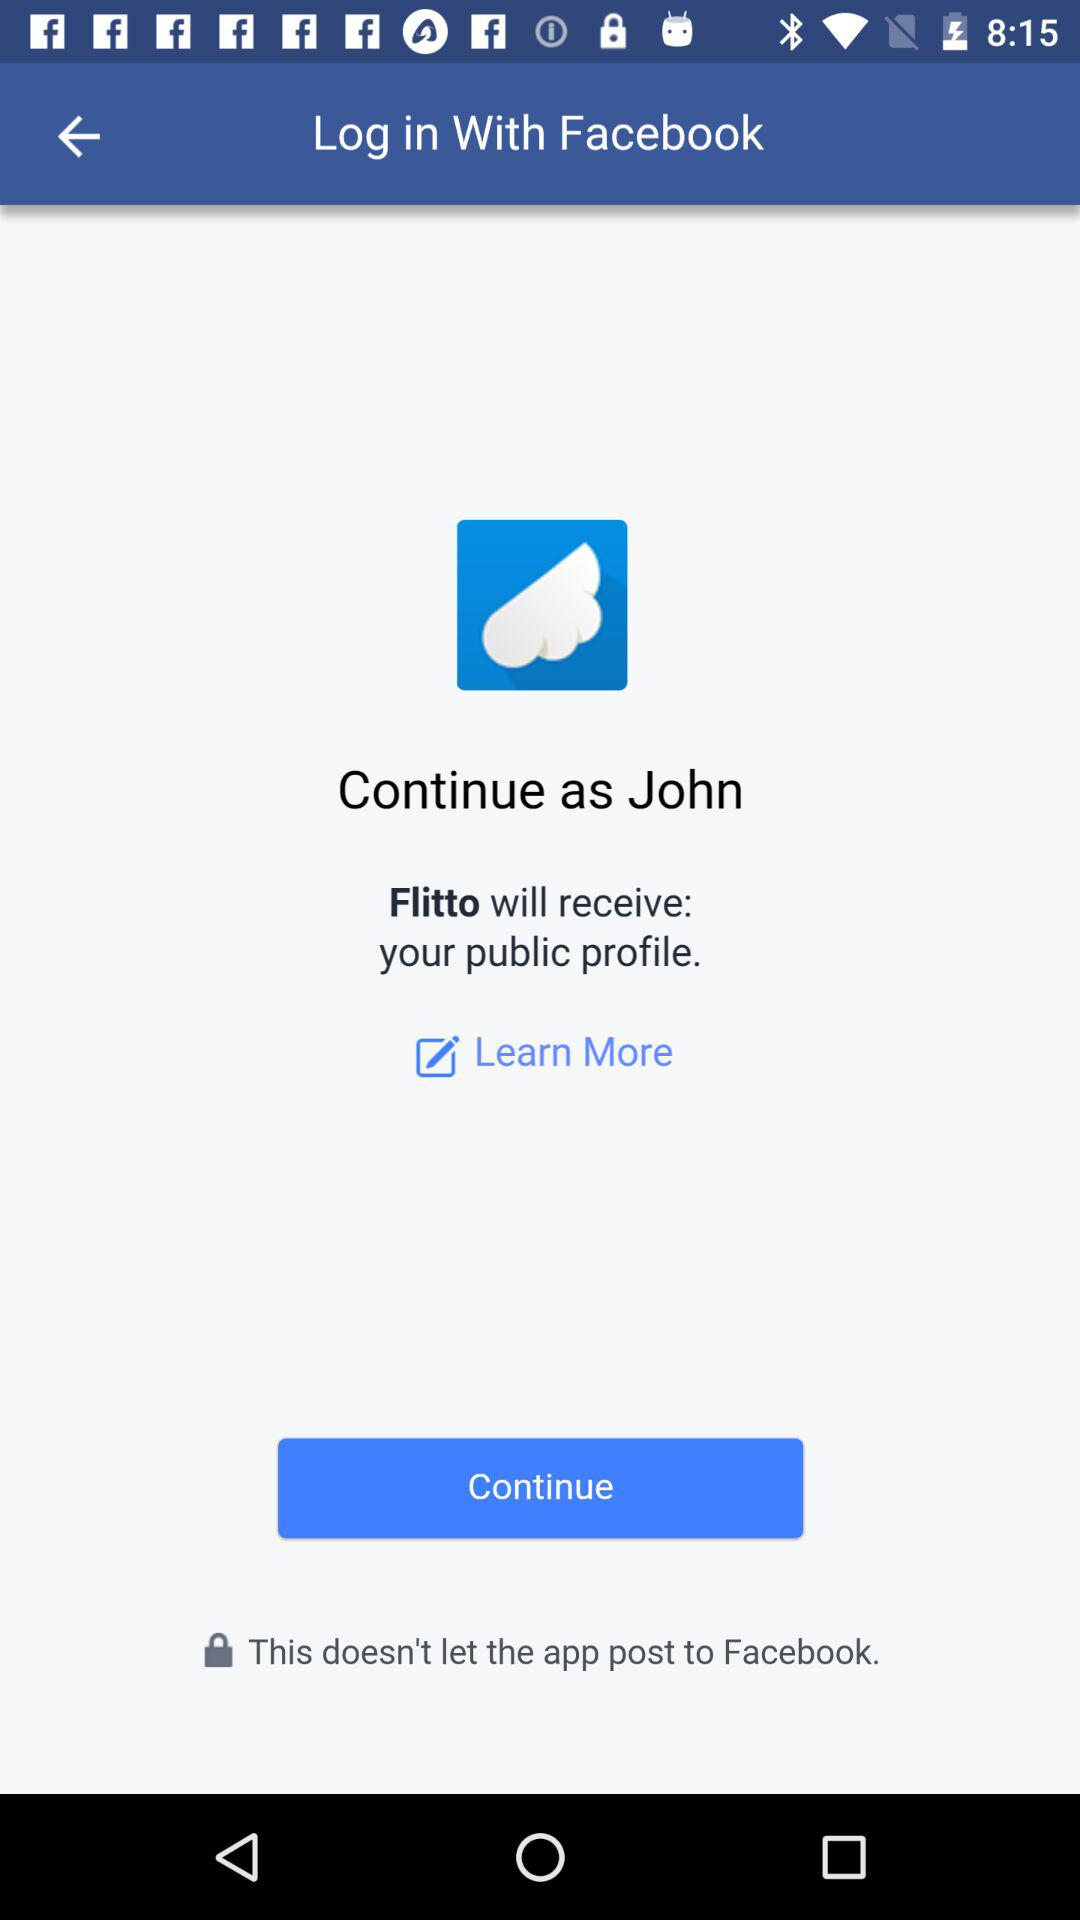What application is asking for permission? The application asking for permission is "Flitto". 